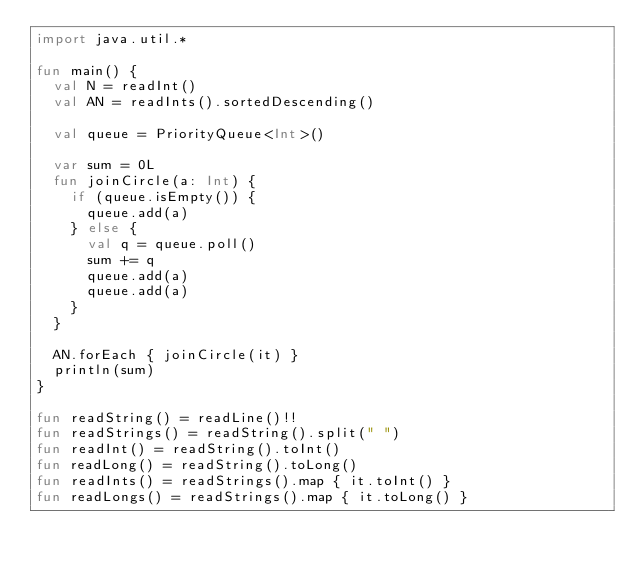<code> <loc_0><loc_0><loc_500><loc_500><_Kotlin_>import java.util.*

fun main() {
  val N = readInt()
  val AN = readInts().sortedDescending()

  val queue = PriorityQueue<Int>()

  var sum = 0L
  fun joinCircle(a: Int) {
    if (queue.isEmpty()) {
      queue.add(a)
    } else {
      val q = queue.poll()
      sum += q
      queue.add(a)
      queue.add(a)
    }
  }

  AN.forEach { joinCircle(it) }
  println(sum)
}

fun readString() = readLine()!!
fun readStrings() = readString().split(" ")
fun readInt() = readString().toInt()
fun readLong() = readString().toLong()
fun readInts() = readStrings().map { it.toInt() }
fun readLongs() = readStrings().map { it.toLong() }
</code> 